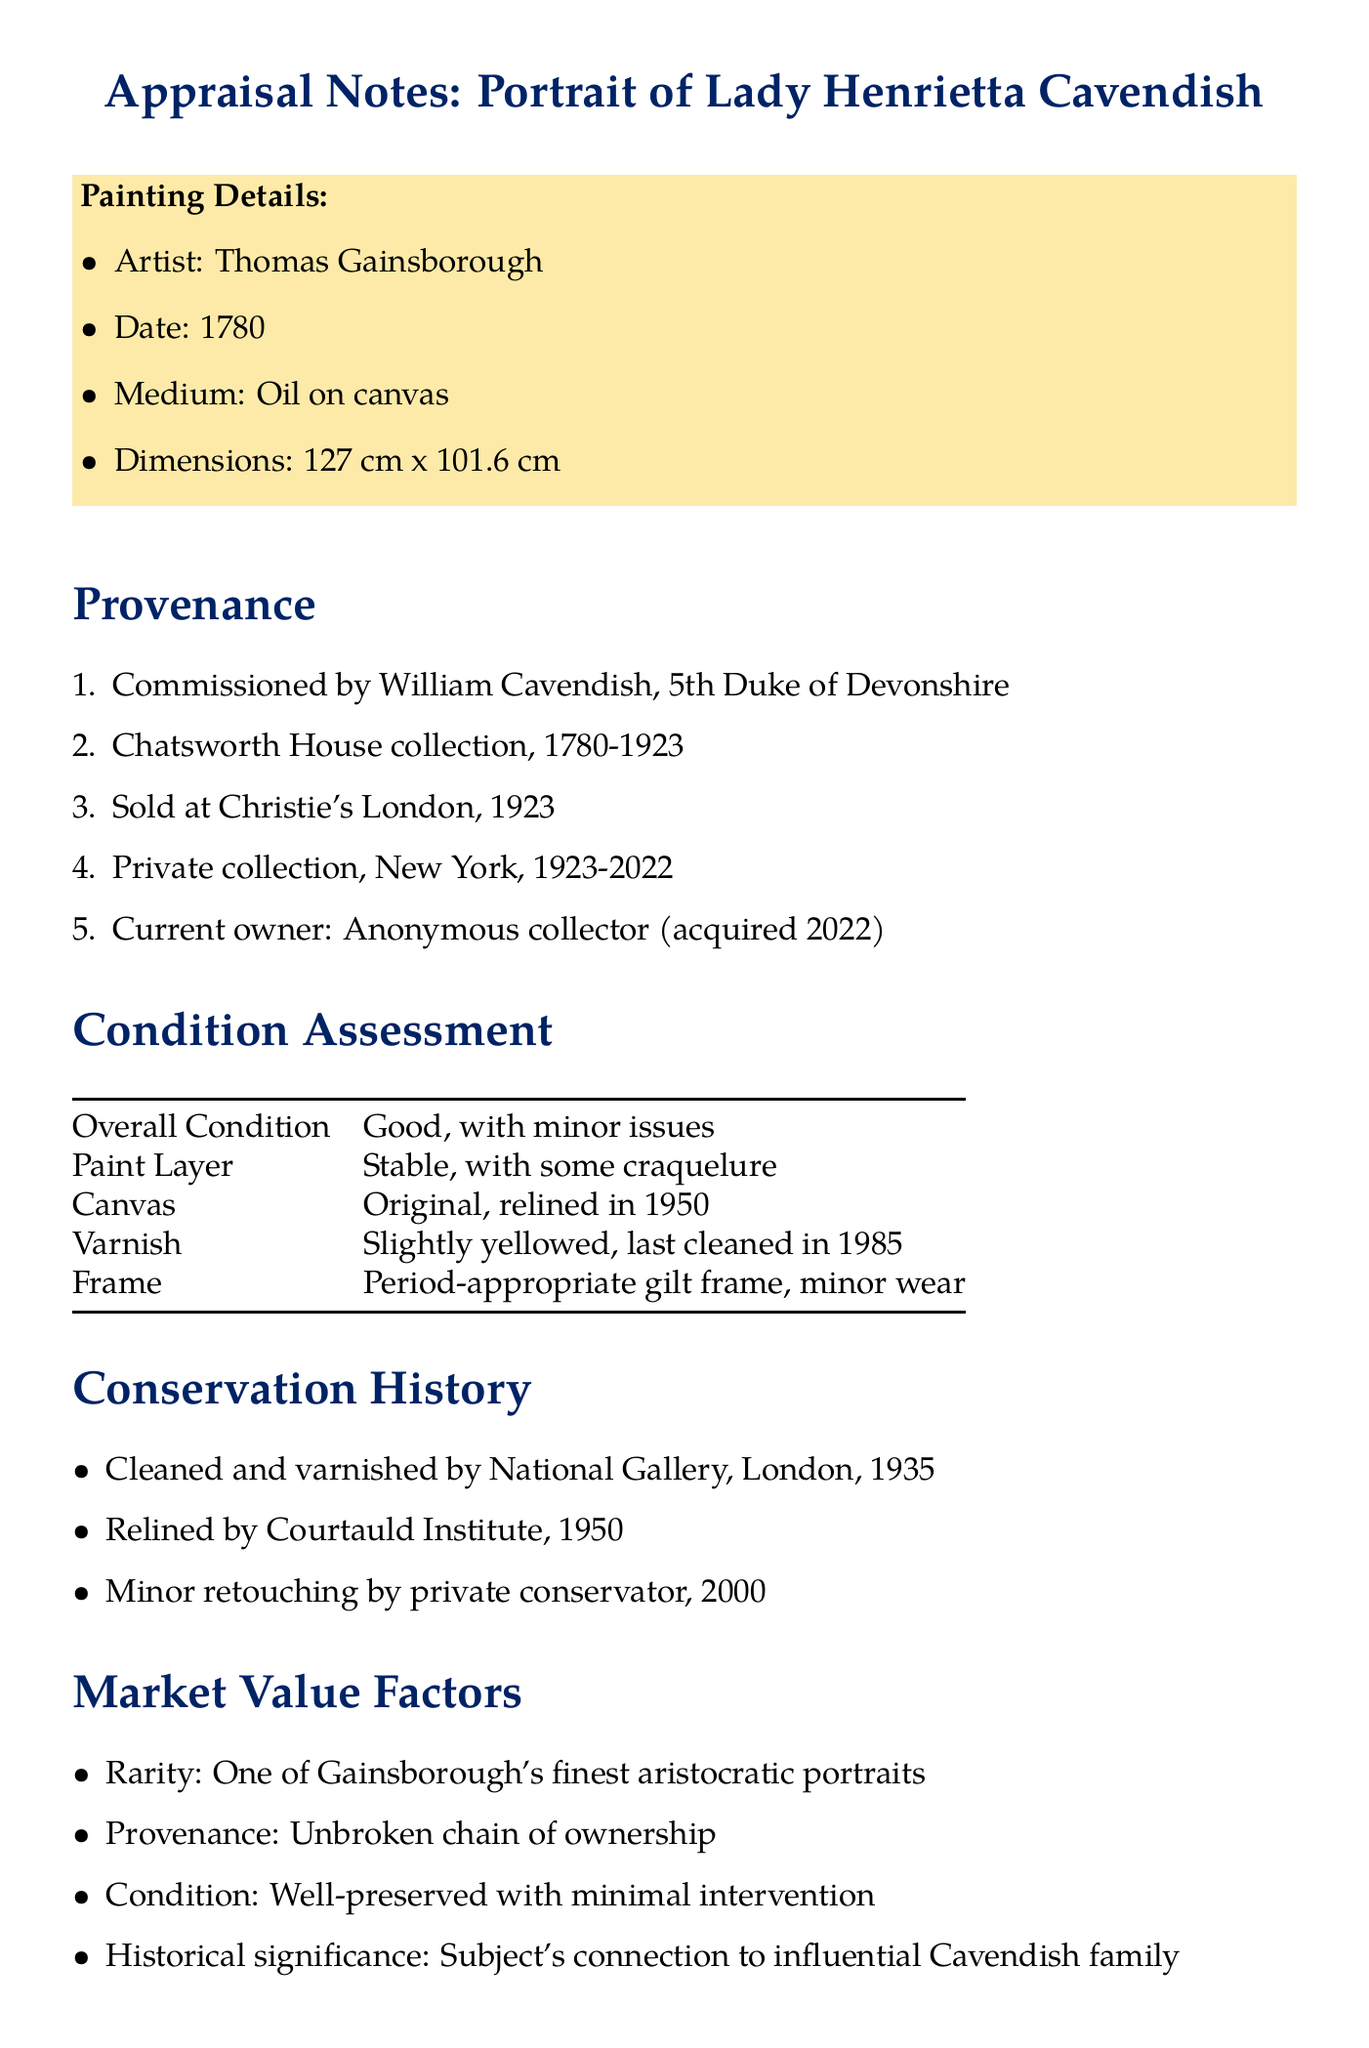What is the title of the painting? The title is specified in the painting details section and refers to the name of the artwork being appraised.
Answer: Portrait of Lady Henrietta Cavendish Who is the artist of the painting? The artist's name is listed in the painting details, indicating who created the artwork.
Answer: Thomas Gainsborough What is the date of the painting? The date is mentioned in the painting details and indicates when the artwork was created.
Answer: 1780 What is the overall condition of the painting? The overall condition is provided in the condition assessment section and describes the status of the artwork.
Answer: Good, with minor issues When was the painting relined? The relining date is included in the conservation history, indicating when the canvas was restored.
Answer: 1950 What notable collection held the painting from 1780 to 1923? This information is found in the provenance section, outlining the painting's history of ownership.
Answer: Chatsworth House collection Who verified the painting's authenticity? The expert opinion is listed in the authentication notes, stating who confirmed the painting's legitimacy.
Answer: Dr. Elizabeth Fulton, Tate Britain What does the varnish condition state? The varnish condition is detailed in the condition assessment and provides insight into the preservation of the surface.
Answer: Slightly yellowed, last cleaned in 1985 Why is the painting considered rare? This reason is provided in the market value factors, explaining why the artwork is unique or special in the market.
Answer: One of Gainsborough's finest aristocratic portraits 